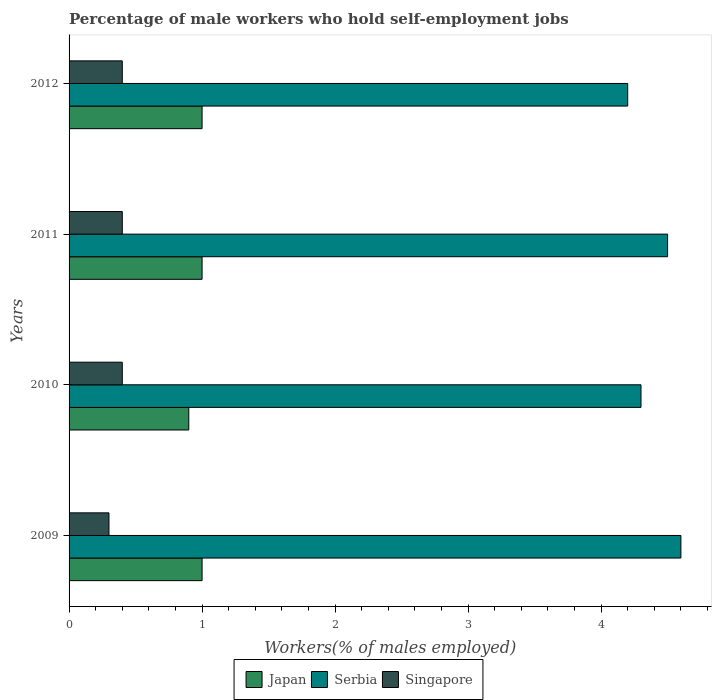How many different coloured bars are there?
Offer a very short reply. 3. How many bars are there on the 4th tick from the top?
Ensure brevity in your answer.  3. What is the label of the 3rd group of bars from the top?
Your answer should be very brief. 2010. What is the percentage of self-employed male workers in Japan in 2012?
Your response must be concise. 1. Across all years, what is the maximum percentage of self-employed male workers in Singapore?
Provide a succinct answer. 0.4. Across all years, what is the minimum percentage of self-employed male workers in Singapore?
Your response must be concise. 0.3. In which year was the percentage of self-employed male workers in Singapore maximum?
Give a very brief answer. 2010. In which year was the percentage of self-employed male workers in Japan minimum?
Provide a short and direct response. 2010. What is the total percentage of self-employed male workers in Serbia in the graph?
Give a very brief answer. 17.6. What is the difference between the percentage of self-employed male workers in Serbia in 2009 and that in 2012?
Offer a terse response. 0.4. What is the difference between the percentage of self-employed male workers in Singapore in 2009 and the percentage of self-employed male workers in Serbia in 2012?
Offer a very short reply. -3.9. What is the average percentage of self-employed male workers in Singapore per year?
Your answer should be very brief. 0.38. In the year 2011, what is the difference between the percentage of self-employed male workers in Singapore and percentage of self-employed male workers in Serbia?
Give a very brief answer. -4.1. What is the ratio of the percentage of self-employed male workers in Singapore in 2009 to that in 2012?
Your answer should be compact. 0.75. Is the difference between the percentage of self-employed male workers in Singapore in 2010 and 2011 greater than the difference between the percentage of self-employed male workers in Serbia in 2010 and 2011?
Give a very brief answer. Yes. What is the difference between the highest and the second highest percentage of self-employed male workers in Singapore?
Give a very brief answer. 0. What is the difference between the highest and the lowest percentage of self-employed male workers in Serbia?
Make the answer very short. 0.4. What does the 2nd bar from the top in 2011 represents?
Your answer should be very brief. Serbia. What does the 1st bar from the bottom in 2012 represents?
Ensure brevity in your answer.  Japan. Are all the bars in the graph horizontal?
Your answer should be very brief. Yes. How many years are there in the graph?
Keep it short and to the point. 4. What is the difference between two consecutive major ticks on the X-axis?
Your response must be concise. 1. Are the values on the major ticks of X-axis written in scientific E-notation?
Offer a terse response. No. Does the graph contain grids?
Your answer should be compact. No. How many legend labels are there?
Ensure brevity in your answer.  3. How are the legend labels stacked?
Offer a very short reply. Horizontal. What is the title of the graph?
Offer a very short reply. Percentage of male workers who hold self-employment jobs. Does "Dominica" appear as one of the legend labels in the graph?
Your response must be concise. No. What is the label or title of the X-axis?
Your answer should be compact. Workers(% of males employed). What is the label or title of the Y-axis?
Offer a very short reply. Years. What is the Workers(% of males employed) of Japan in 2009?
Provide a succinct answer. 1. What is the Workers(% of males employed) of Serbia in 2009?
Keep it short and to the point. 4.6. What is the Workers(% of males employed) of Singapore in 2009?
Offer a very short reply. 0.3. What is the Workers(% of males employed) in Japan in 2010?
Ensure brevity in your answer.  0.9. What is the Workers(% of males employed) of Serbia in 2010?
Offer a very short reply. 4.3. What is the Workers(% of males employed) of Singapore in 2010?
Offer a very short reply. 0.4. What is the Workers(% of males employed) in Singapore in 2011?
Your answer should be compact. 0.4. What is the Workers(% of males employed) in Serbia in 2012?
Ensure brevity in your answer.  4.2. What is the Workers(% of males employed) in Singapore in 2012?
Make the answer very short. 0.4. Across all years, what is the maximum Workers(% of males employed) of Serbia?
Your answer should be very brief. 4.6. Across all years, what is the maximum Workers(% of males employed) of Singapore?
Give a very brief answer. 0.4. Across all years, what is the minimum Workers(% of males employed) in Japan?
Provide a short and direct response. 0.9. Across all years, what is the minimum Workers(% of males employed) in Serbia?
Keep it short and to the point. 4.2. Across all years, what is the minimum Workers(% of males employed) of Singapore?
Keep it short and to the point. 0.3. What is the total Workers(% of males employed) of Japan in the graph?
Your answer should be compact. 3.9. What is the total Workers(% of males employed) of Singapore in the graph?
Provide a short and direct response. 1.5. What is the difference between the Workers(% of males employed) of Serbia in 2009 and that in 2011?
Make the answer very short. 0.1. What is the difference between the Workers(% of males employed) of Singapore in 2009 and that in 2011?
Offer a terse response. -0.1. What is the difference between the Workers(% of males employed) in Japan in 2009 and that in 2012?
Provide a succinct answer. 0. What is the difference between the Workers(% of males employed) in Serbia in 2009 and that in 2012?
Provide a short and direct response. 0.4. What is the difference between the Workers(% of males employed) in Japan in 2010 and that in 2011?
Make the answer very short. -0.1. What is the difference between the Workers(% of males employed) of Japan in 2010 and that in 2012?
Give a very brief answer. -0.1. What is the difference between the Workers(% of males employed) of Serbia in 2011 and that in 2012?
Provide a succinct answer. 0.3. What is the difference between the Workers(% of males employed) of Singapore in 2011 and that in 2012?
Keep it short and to the point. 0. What is the difference between the Workers(% of males employed) of Japan in 2009 and the Workers(% of males employed) of Singapore in 2010?
Your response must be concise. 0.6. What is the difference between the Workers(% of males employed) of Serbia in 2009 and the Workers(% of males employed) of Singapore in 2010?
Provide a succinct answer. 4.2. What is the difference between the Workers(% of males employed) in Japan in 2009 and the Workers(% of males employed) in Singapore in 2011?
Keep it short and to the point. 0.6. What is the difference between the Workers(% of males employed) in Japan in 2009 and the Workers(% of males employed) in Serbia in 2012?
Offer a very short reply. -3.2. What is the difference between the Workers(% of males employed) of Japan in 2010 and the Workers(% of males employed) of Serbia in 2011?
Offer a terse response. -3.6. What is the difference between the Workers(% of males employed) in Japan in 2010 and the Workers(% of males employed) in Singapore in 2012?
Make the answer very short. 0.5. What is the difference between the Workers(% of males employed) in Serbia in 2010 and the Workers(% of males employed) in Singapore in 2012?
Make the answer very short. 3.9. What is the difference between the Workers(% of males employed) in Japan in 2011 and the Workers(% of males employed) in Serbia in 2012?
Provide a short and direct response. -3.2. What is the difference between the Workers(% of males employed) of Japan in 2011 and the Workers(% of males employed) of Singapore in 2012?
Ensure brevity in your answer.  0.6. What is the difference between the Workers(% of males employed) of Serbia in 2011 and the Workers(% of males employed) of Singapore in 2012?
Offer a very short reply. 4.1. What is the average Workers(% of males employed) of Serbia per year?
Your answer should be very brief. 4.4. In the year 2009, what is the difference between the Workers(% of males employed) in Japan and Workers(% of males employed) in Serbia?
Your answer should be compact. -3.6. In the year 2010, what is the difference between the Workers(% of males employed) in Japan and Workers(% of males employed) in Singapore?
Make the answer very short. 0.5. In the year 2011, what is the difference between the Workers(% of males employed) in Japan and Workers(% of males employed) in Serbia?
Give a very brief answer. -3.5. In the year 2012, what is the difference between the Workers(% of males employed) in Japan and Workers(% of males employed) in Serbia?
Give a very brief answer. -3.2. In the year 2012, what is the difference between the Workers(% of males employed) of Japan and Workers(% of males employed) of Singapore?
Keep it short and to the point. 0.6. In the year 2012, what is the difference between the Workers(% of males employed) of Serbia and Workers(% of males employed) of Singapore?
Provide a succinct answer. 3.8. What is the ratio of the Workers(% of males employed) of Serbia in 2009 to that in 2010?
Keep it short and to the point. 1.07. What is the ratio of the Workers(% of males employed) in Singapore in 2009 to that in 2010?
Your response must be concise. 0.75. What is the ratio of the Workers(% of males employed) of Serbia in 2009 to that in 2011?
Give a very brief answer. 1.02. What is the ratio of the Workers(% of males employed) in Singapore in 2009 to that in 2011?
Provide a short and direct response. 0.75. What is the ratio of the Workers(% of males employed) in Serbia in 2009 to that in 2012?
Provide a succinct answer. 1.1. What is the ratio of the Workers(% of males employed) of Singapore in 2009 to that in 2012?
Offer a very short reply. 0.75. What is the ratio of the Workers(% of males employed) of Japan in 2010 to that in 2011?
Your response must be concise. 0.9. What is the ratio of the Workers(% of males employed) of Serbia in 2010 to that in 2011?
Make the answer very short. 0.96. What is the ratio of the Workers(% of males employed) in Singapore in 2010 to that in 2011?
Give a very brief answer. 1. What is the ratio of the Workers(% of males employed) of Serbia in 2010 to that in 2012?
Make the answer very short. 1.02. What is the ratio of the Workers(% of males employed) of Serbia in 2011 to that in 2012?
Your answer should be very brief. 1.07. What is the difference between the highest and the second highest Workers(% of males employed) in Serbia?
Offer a very short reply. 0.1. What is the difference between the highest and the lowest Workers(% of males employed) in Japan?
Your answer should be very brief. 0.1. What is the difference between the highest and the lowest Workers(% of males employed) in Singapore?
Give a very brief answer. 0.1. 